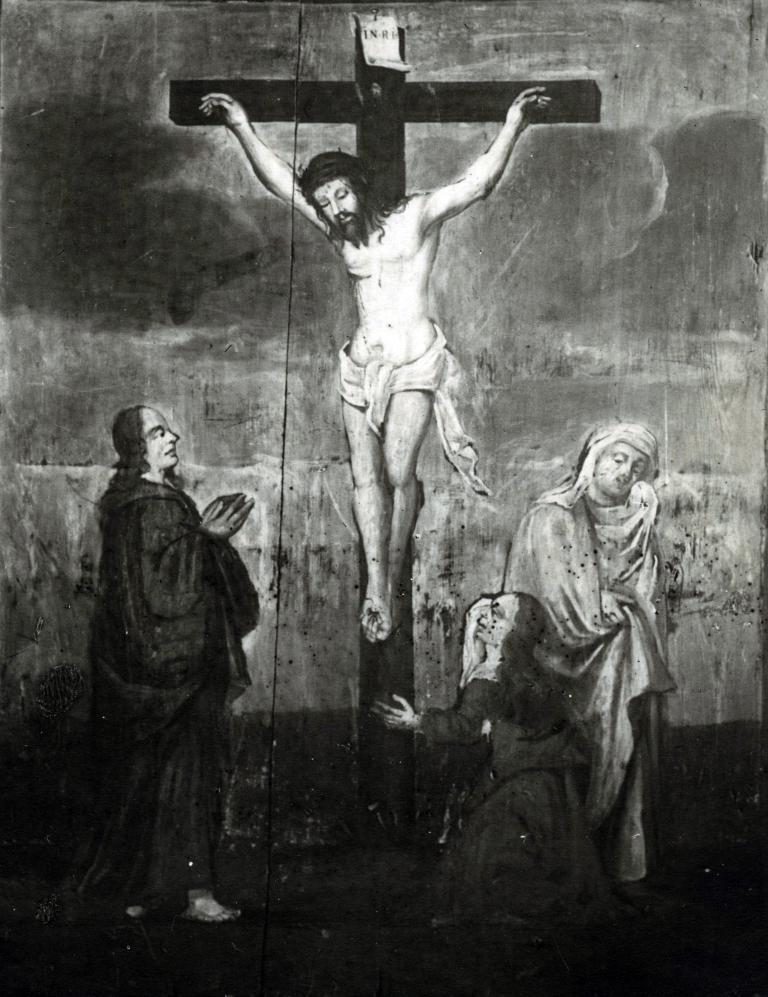In one or two sentences, can you explain what this image depicts? In the picture I can see a sketch of the Jesus and some other persons. The picture is black and white in color. 